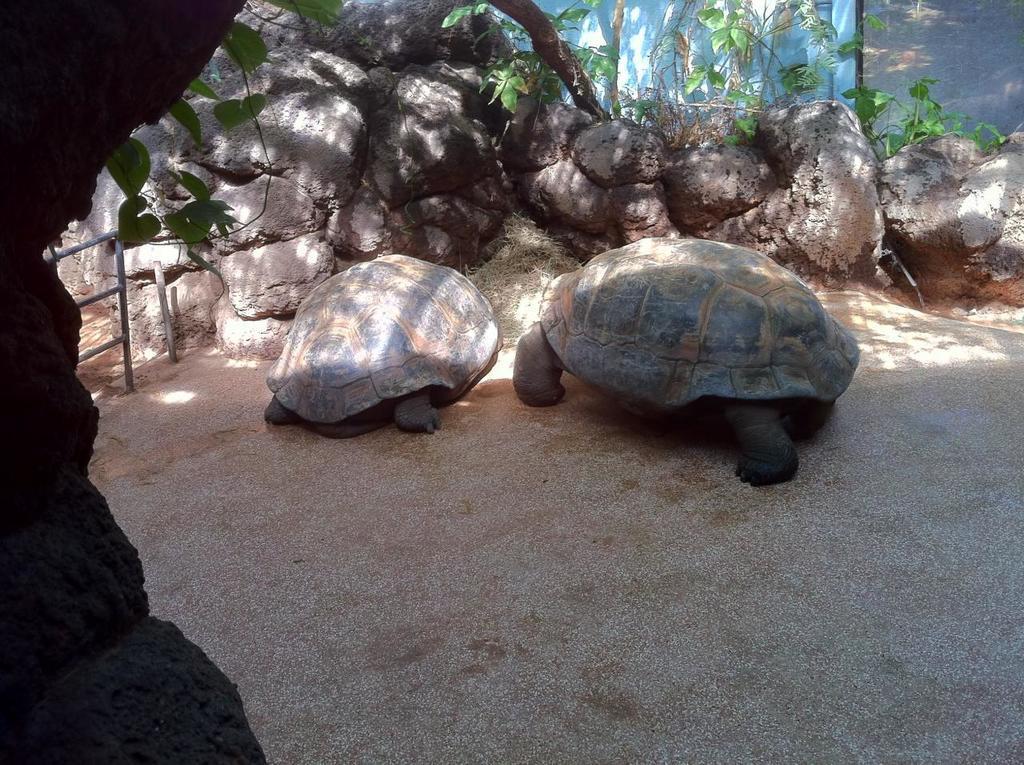Can you describe this image briefly? In front of the image there are two turtles, behind them there are rocks, trees, metal rod fence and a wall. On the left side of the image there is a tree. 